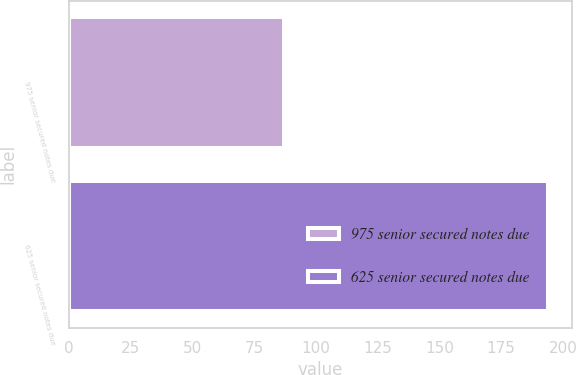<chart> <loc_0><loc_0><loc_500><loc_500><bar_chart><fcel>975 senior secured notes due<fcel>625 senior secured notes due<nl><fcel>87<fcel>194<nl></chart> 